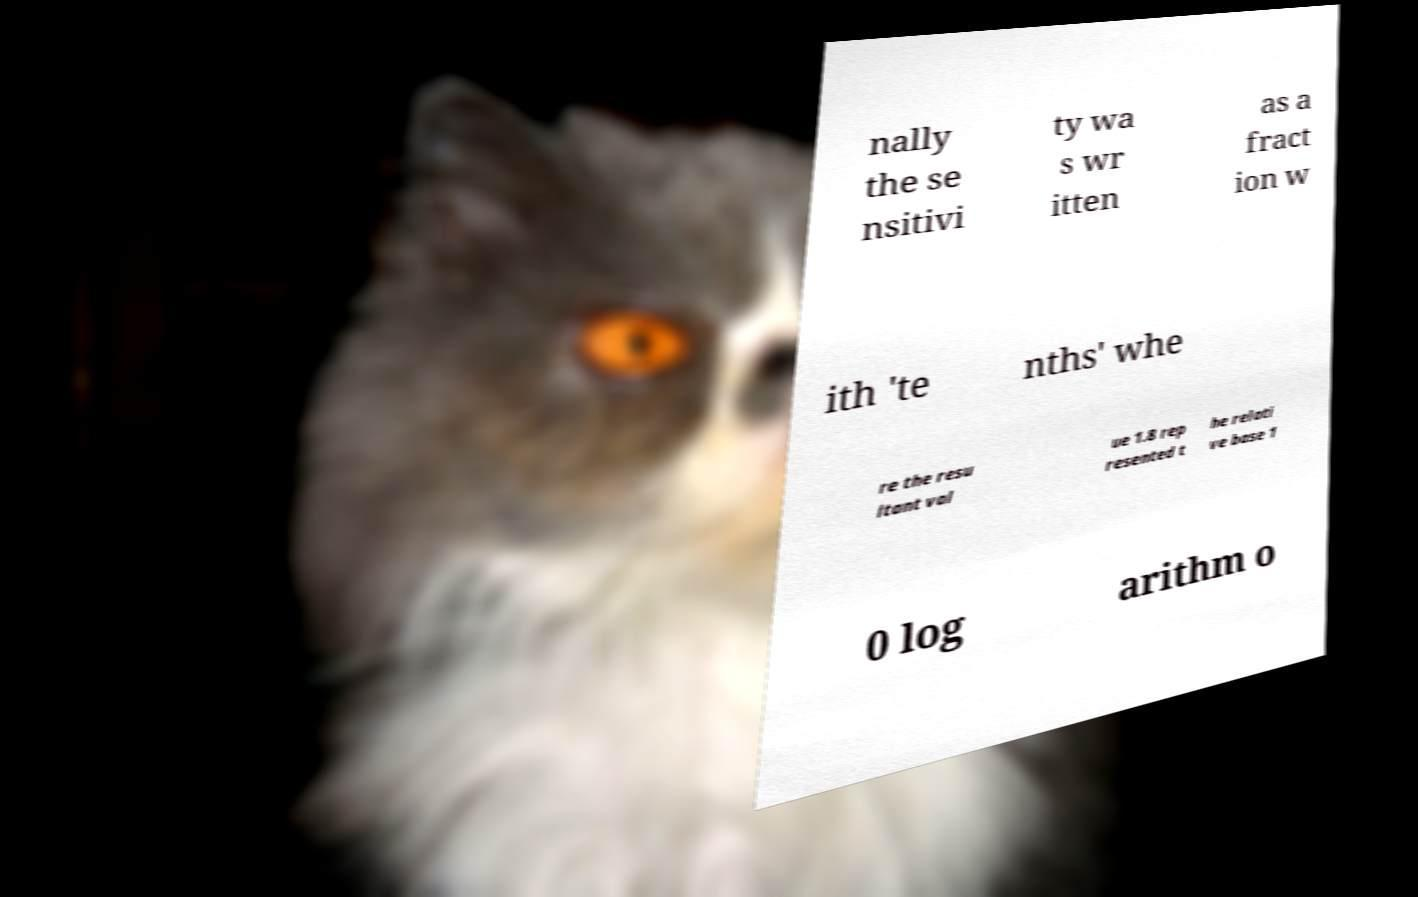Can you read and provide the text displayed in the image?This photo seems to have some interesting text. Can you extract and type it out for me? nally the se nsitivi ty wa s wr itten as a fract ion w ith 'te nths' whe re the resu ltant val ue 1.8 rep resented t he relati ve base 1 0 log arithm o 